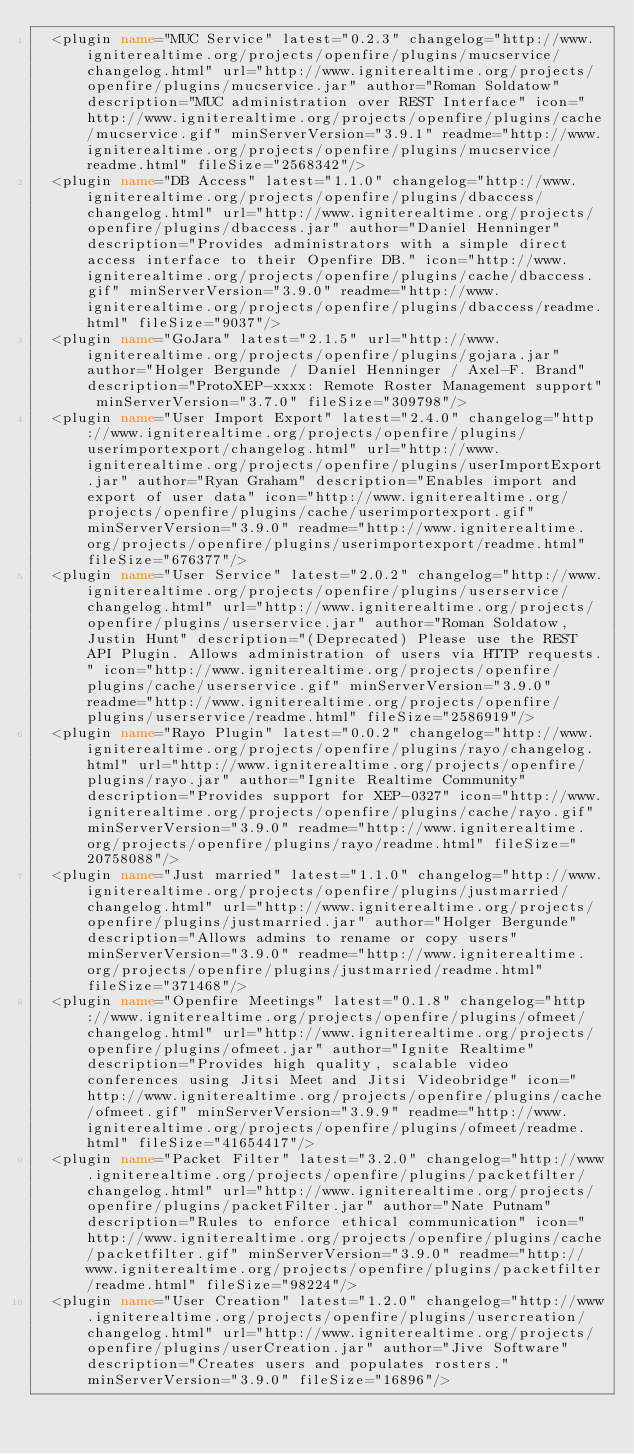Convert code to text. <code><loc_0><loc_0><loc_500><loc_500><_XML_>  <plugin name="MUC Service" latest="0.2.3" changelog="http://www.igniterealtime.org/projects/openfire/plugins/mucservice/changelog.html" url="http://www.igniterealtime.org/projects/openfire/plugins/mucservice.jar" author="Roman Soldatow" description="MUC administration over REST Interface" icon="http://www.igniterealtime.org/projects/openfire/plugins/cache/mucservice.gif" minServerVersion="3.9.1" readme="http://www.igniterealtime.org/projects/openfire/plugins/mucservice/readme.html" fileSize="2568342"/> 
  <plugin name="DB Access" latest="1.1.0" changelog="http://www.igniterealtime.org/projects/openfire/plugins/dbaccess/changelog.html" url="http://www.igniterealtime.org/projects/openfire/plugins/dbaccess.jar" author="Daniel Henninger" description="Provides administrators with a simple direct access interface to their Openfire DB." icon="http://www.igniterealtime.org/projects/openfire/plugins/cache/dbaccess.gif" minServerVersion="3.9.0" readme="http://www.igniterealtime.org/projects/openfire/plugins/dbaccess/readme.html" fileSize="9037"/> 
  <plugin name="GoJara" latest="2.1.5" url="http://www.igniterealtime.org/projects/openfire/plugins/gojara.jar" author="Holger Bergunde / Daniel Henninger / Axel-F. Brand" description="ProtoXEP-xxxx: Remote Roster Management support" minServerVersion="3.7.0" fileSize="309798"/> 
  <plugin name="User Import Export" latest="2.4.0" changelog="http://www.igniterealtime.org/projects/openfire/plugins/userimportexport/changelog.html" url="http://www.igniterealtime.org/projects/openfire/plugins/userImportExport.jar" author="Ryan Graham" description="Enables import and export of user data" icon="http://www.igniterealtime.org/projects/openfire/plugins/cache/userimportexport.gif" minServerVersion="3.9.0" readme="http://www.igniterealtime.org/projects/openfire/plugins/userimportexport/readme.html" fileSize="676377"/> 
  <plugin name="User Service" latest="2.0.2" changelog="http://www.igniterealtime.org/projects/openfire/plugins/userservice/changelog.html" url="http://www.igniterealtime.org/projects/openfire/plugins/userservice.jar" author="Roman Soldatow, Justin Hunt" description="(Deprecated) Please use the REST API Plugin. Allows administration of users via HTTP requests." icon="http://www.igniterealtime.org/projects/openfire/plugins/cache/userservice.gif" minServerVersion="3.9.0" readme="http://www.igniterealtime.org/projects/openfire/plugins/userservice/readme.html" fileSize="2586919"/> 
  <plugin name="Rayo Plugin" latest="0.0.2" changelog="http://www.igniterealtime.org/projects/openfire/plugins/rayo/changelog.html" url="http://www.igniterealtime.org/projects/openfire/plugins/rayo.jar" author="Ignite Realtime Community" description="Provides support for XEP-0327" icon="http://www.igniterealtime.org/projects/openfire/plugins/cache/rayo.gif" minServerVersion="3.9.0" readme="http://www.igniterealtime.org/projects/openfire/plugins/rayo/readme.html" fileSize="20758088"/> 
  <plugin name="Just married" latest="1.1.0" changelog="http://www.igniterealtime.org/projects/openfire/plugins/justmarried/changelog.html" url="http://www.igniterealtime.org/projects/openfire/plugins/justmarried.jar" author="Holger Bergunde" description="Allows admins to rename or copy users" minServerVersion="3.9.0" readme="http://www.igniterealtime.org/projects/openfire/plugins/justmarried/readme.html" fileSize="371468"/> 
  <plugin name="Openfire Meetings" latest="0.1.8" changelog="http://www.igniterealtime.org/projects/openfire/plugins/ofmeet/changelog.html" url="http://www.igniterealtime.org/projects/openfire/plugins/ofmeet.jar" author="Ignite Realtime" description="Provides high quality, scalable video conferences using Jitsi Meet and Jitsi Videobridge" icon="http://www.igniterealtime.org/projects/openfire/plugins/cache/ofmeet.gif" minServerVersion="3.9.9" readme="http://www.igniterealtime.org/projects/openfire/plugins/ofmeet/readme.html" fileSize="41654417"/> 
  <plugin name="Packet Filter" latest="3.2.0" changelog="http://www.igniterealtime.org/projects/openfire/plugins/packetfilter/changelog.html" url="http://www.igniterealtime.org/projects/openfire/plugins/packetFilter.jar" author="Nate Putnam" description="Rules to enforce ethical communication" icon="http://www.igniterealtime.org/projects/openfire/plugins/cache/packetfilter.gif" minServerVersion="3.9.0" readme="http://www.igniterealtime.org/projects/openfire/plugins/packetfilter/readme.html" fileSize="98224"/> 
  <plugin name="User Creation" latest="1.2.0" changelog="http://www.igniterealtime.org/projects/openfire/plugins/usercreation/changelog.html" url="http://www.igniterealtime.org/projects/openfire/plugins/userCreation.jar" author="Jive Software" description="Creates users and populates rosters." minServerVersion="3.9.0" fileSize="16896"/> </code> 